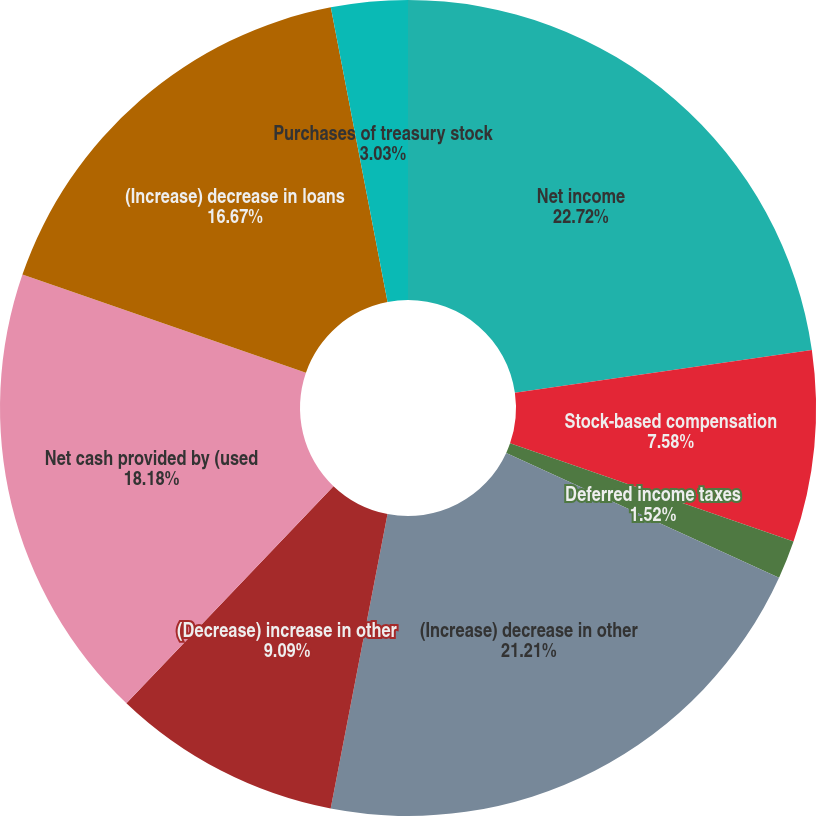Convert chart. <chart><loc_0><loc_0><loc_500><loc_500><pie_chart><fcel>Net income<fcel>Stock-based compensation<fcel>Deferred income taxes<fcel>Depreciation and amortization<fcel>(Increase) decrease in other<fcel>(Decrease) increase in other<fcel>Net cash provided by (used<fcel>(Increase) decrease in loans<fcel>Purchases of treasury stock<nl><fcel>22.73%<fcel>7.58%<fcel>1.52%<fcel>0.0%<fcel>21.21%<fcel>9.09%<fcel>18.18%<fcel>16.67%<fcel>3.03%<nl></chart> 